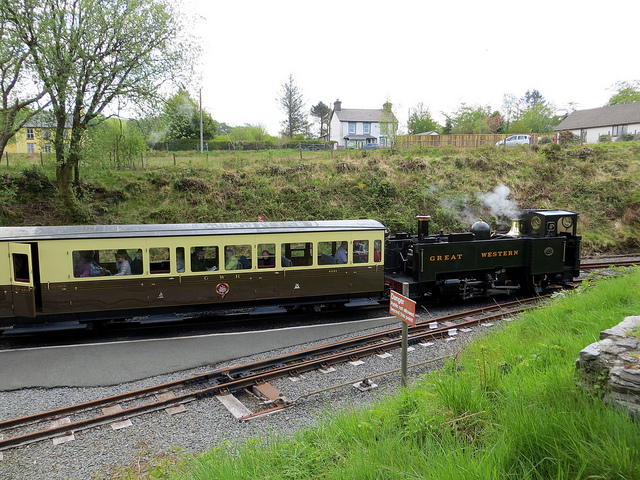Identify and read out the text in this image. GREAT WESTERN 